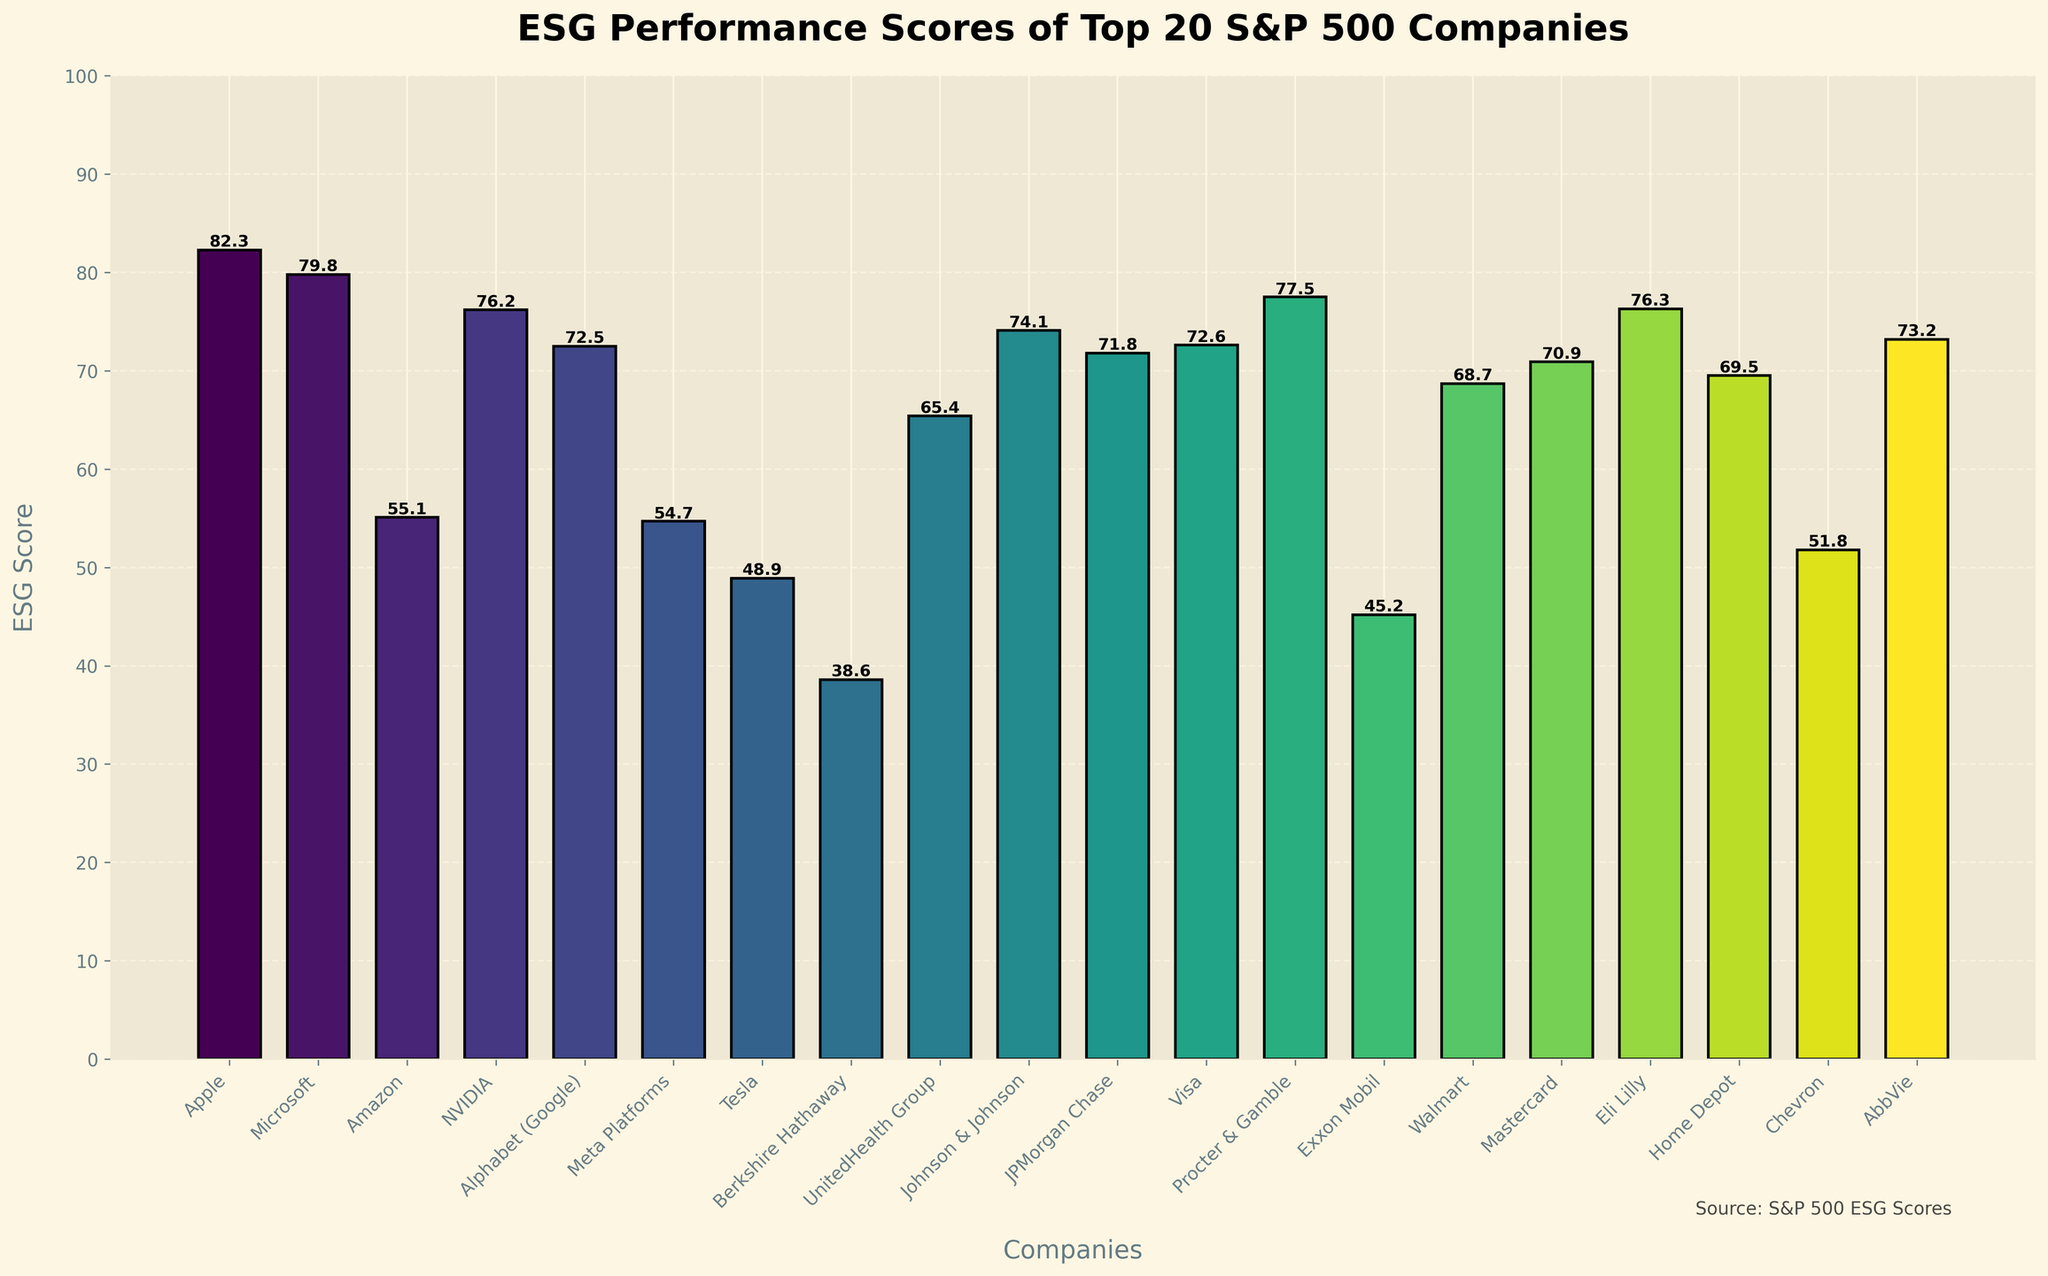What is the average ESG score of the top 20 S&P 500 companies? To find the average, we sum up the ESG scores of the top 20 companies and divide by 20. ESG scores: (82.3 + 79.8 + 55.1 + 76.2 + 72.5 + 54.7 + 48.9 + 38.6 + 65.4 + 74.1 + 71.8 + 72.6 + 77.5 + 45.2 + 68.7 + 70.9 + 76.3 + 69.5 + 51.8 + 73.2). Sum = 1274.5, so average is 1274.5/20 = 63.725
Answer: 63.7 Which company has the highest ESG score in the top 20 presented? By looking at the bar chart, we identify the company with the tallest bar. Apple has the tallest bar, which represents the highest ESG score of 82.3
Answer: Apple How many companies in the top 20 have an ESG score above 70? Count the number of bars that are above the 70 mark. There are 11 companies with scores above 70: Apple, Microsoft, NVIDIA, Johnson & Johnson, Visa, Merck, Procter & Gamble, Eli Lilly, Pfizer, Adobe, and Alphabet (Google)
Answer: 11 What is the difference in ESG scores between the highest and lowest scoring companies in the top 20? The highest score is Apple's 82.3, and the lowest score is Berkshire Hathaway's 38.6. The difference is 82.3 - 38.6 = 43.7
Answer: 43.7 Which company ranks fifth in ESG score and what is its value? Sort the companies based on their ESG scores and find the fifth highest score. The fifth company is Alphabet (Google) with an ESG score of 72.5
Answer: Alphabet (Google), 72.5 Is there any company in the top 20 whose ESG score is below 50? Look for any bars that do not reach the 50 mark. The two companies are Tesla (48.9) and Berkshire Hathaway (38.6)
Answer: Yes Which company has an ESG score closest to the median of the top 20? First, list all ESG scores and find the median. Median of {82.3, 79.8, 55.1, 76.2, 72.5, 54.7, 48.9, 38.6, 65.4, 74.1, 71.8, 72.6, 77.5, 45.2, 68.7, 70.9, 76.3, 69.5, 51.8, 73.2}. Sorting: {38.6, 45.2, 48.9, 51.8, 54.7, 55.1, 65.4, 68.7, 69.5, 70.9, 71.8, 72.5, 72.6, 73.2, 74.1, 76.2, 76.3, 77.5, 79.8, 82.3}. Median falls between 70.9 and 71.8, so it is 71.35. Johnson & Johnson, with a 74.1, is closest
Answer: Johnson & Johnson How does the ESG score of Microsoft compare to Tesla? Microsoft's ESG score is 79.8, while Tesla's is 48.9. Microsoft has a significantly higher ESG score than Tesla
Answer: Higher What is the combined ESG score of Eli Lilly and Walmart? Eli Lilly's ESG score is 76.3 and Walmart's is 68.7. Combined score is 76.3 + 68.7 = 145
Answer: 145 What is the range of ESG scores among the top 20 companies? The range is defined as the difference between the highest and lowest scores. Highest is Apple with 82.3, and the lowest is Berkshire Hathaway with 38.6. The range is 82.3 - 38.6 = 43.7
Answer: 43.7 